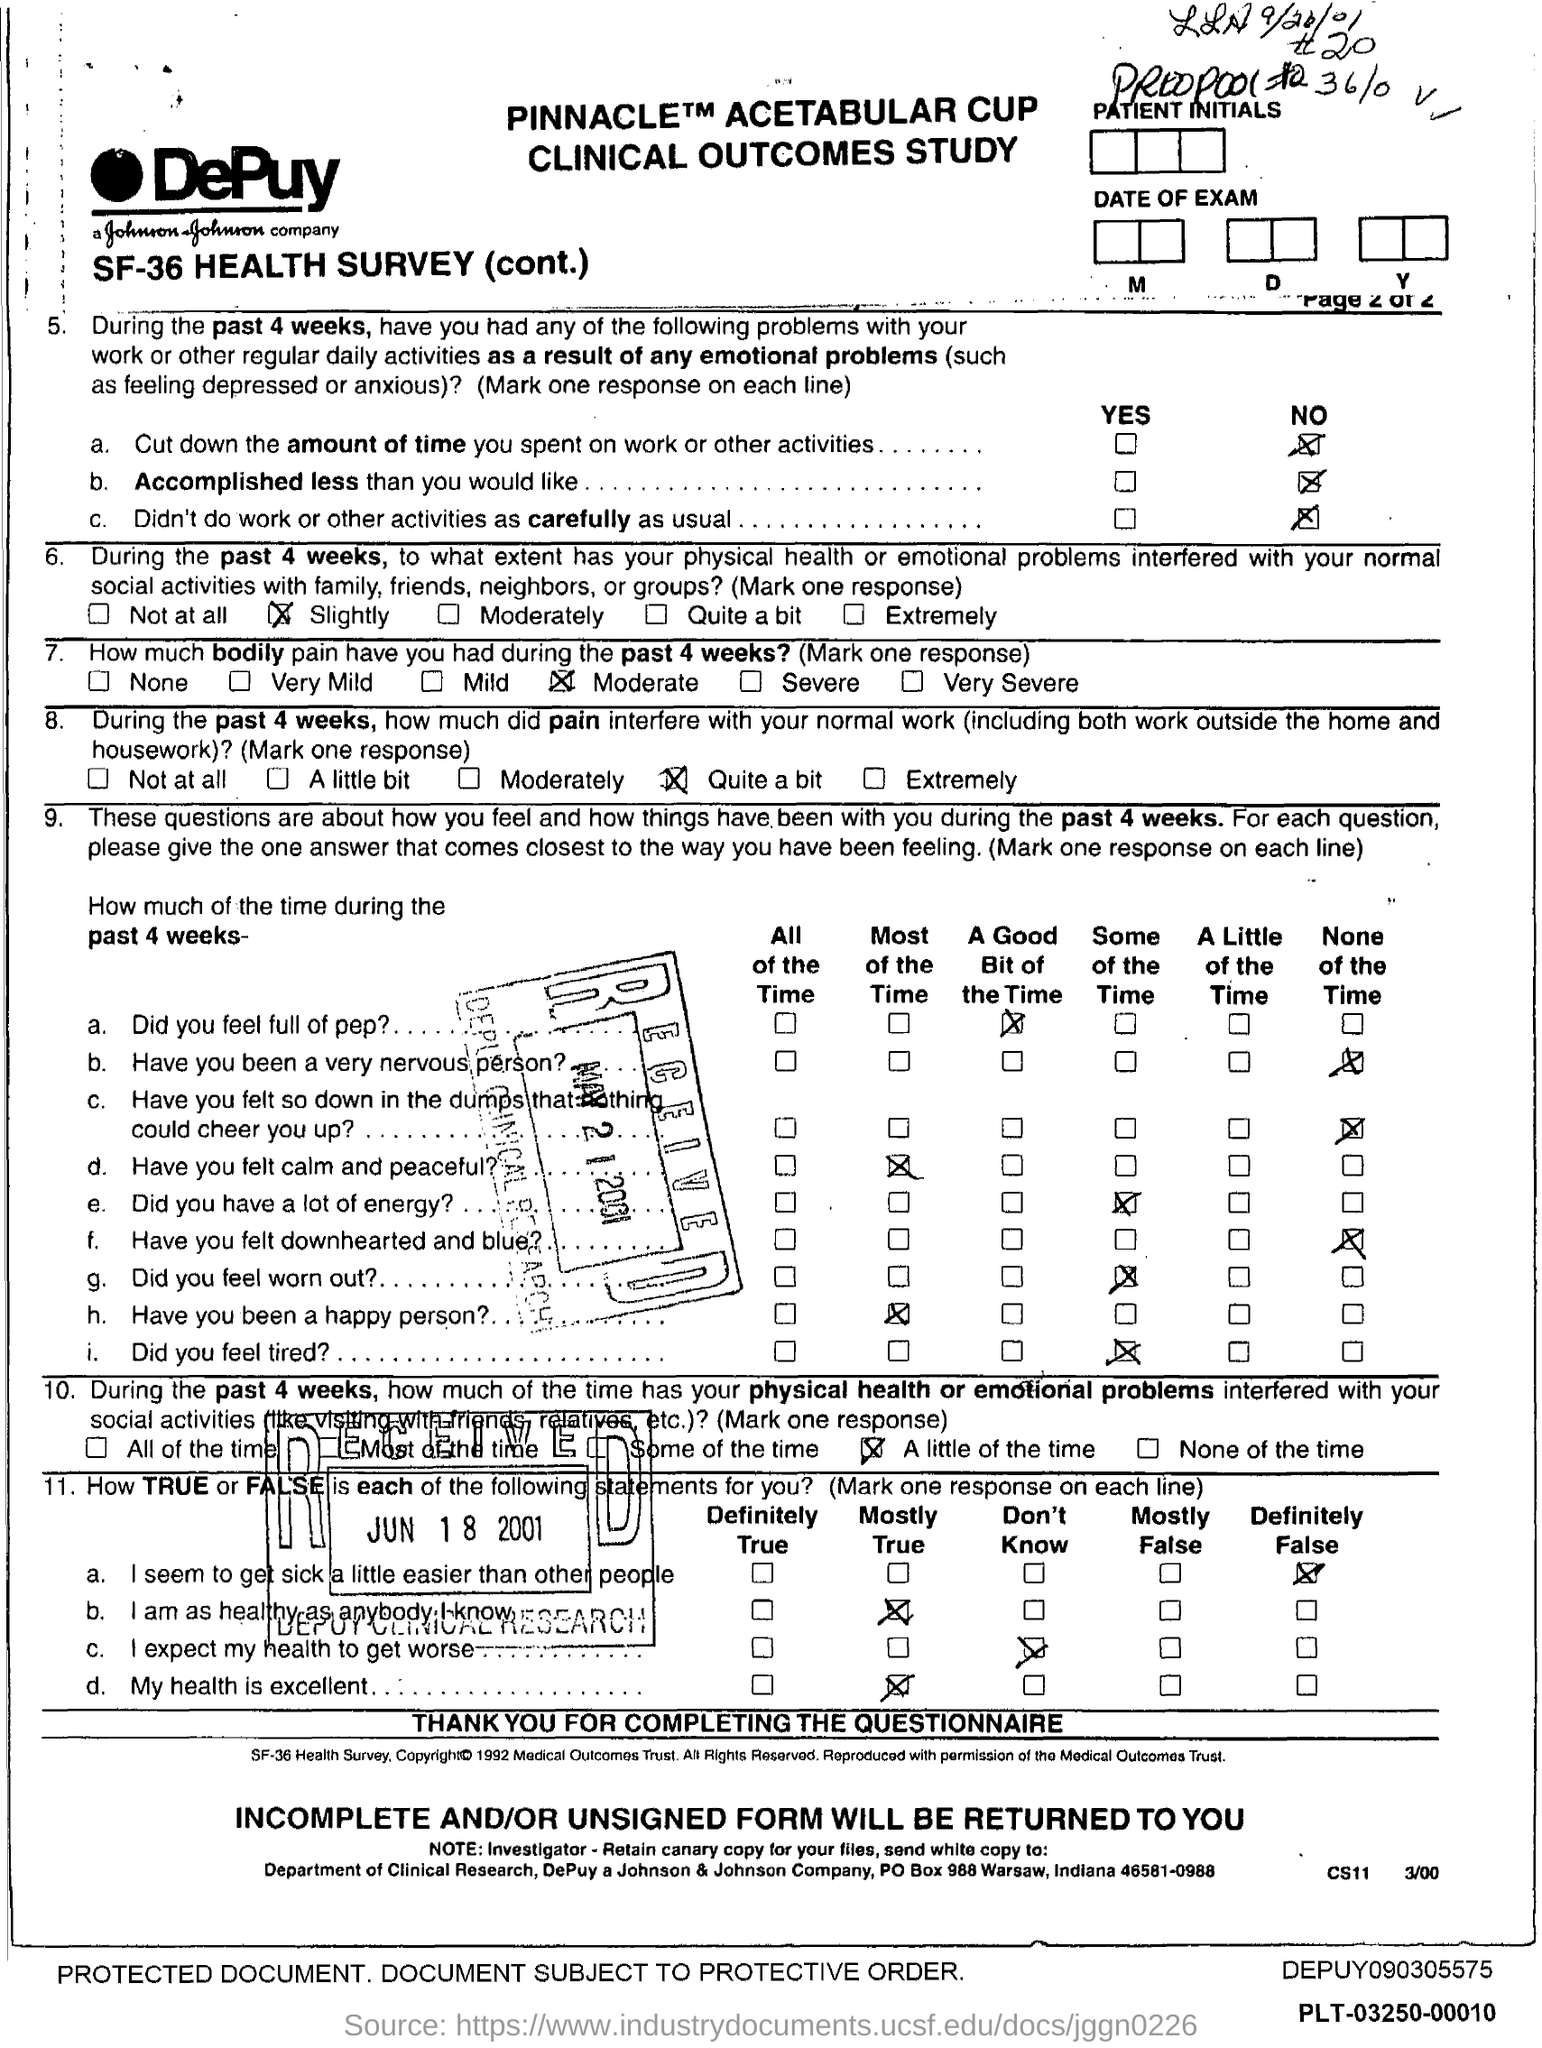What is the title of the ducument?
Make the answer very short. Pinnacle Acetabular Cup clinical outcomes study. What is the company name?
Your answer should be compact. DePuy. Did the patient accomplish less than he/she would like?
Provide a succinct answer. No. How much bodily pain did the patient have during past 4 weeks?
Offer a terse response. Moderate. Has the patient felt calm and peaceful?
Offer a terse response. Most of the time. Which state is the DePuy company in?
Keep it short and to the point. Indiana. The white copy should be sent to which department?
Provide a succinct answer. Department of Clinical Research. How true or false did the patient seem to get sick little easier than other people?
Make the answer very short. Definitely false. What is the date mentioned in the bottom most stamp?
Ensure brevity in your answer.  Jun 18 2001. Has the patient been a happy person?
Make the answer very short. Most of the time. 